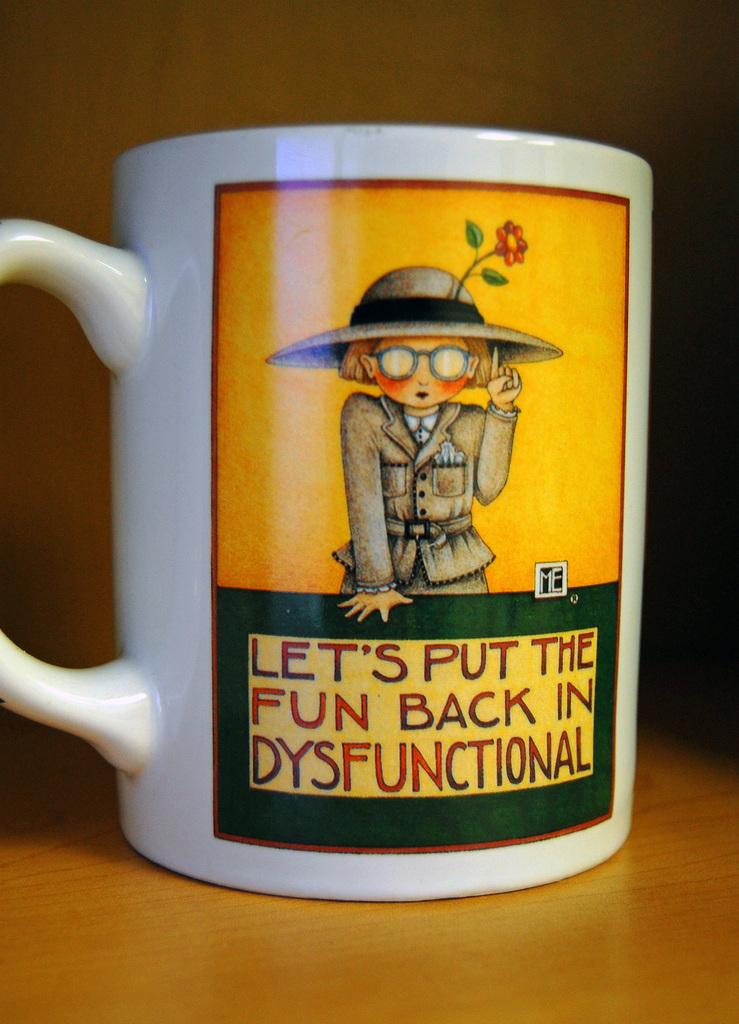<image>
Relay a brief, clear account of the picture shown. Cup with a woman wearing a hat and the words Let's put the fun back in dysfunctional. 